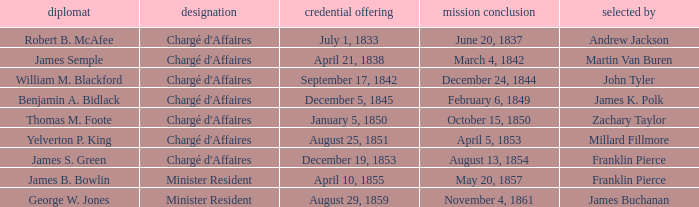What's the Termination of Mission listed that has a Presentation of Credentials for August 29, 1859? November 4, 1861. 